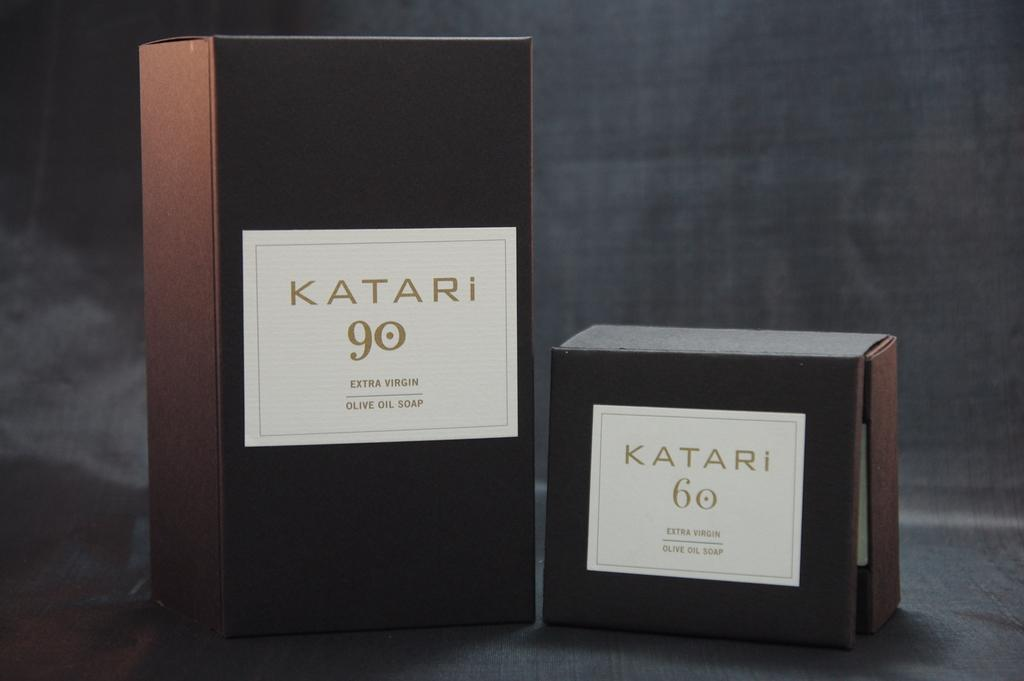<image>
Provide a brief description of the given image. two boxes of Katari 90 olive oil soap 